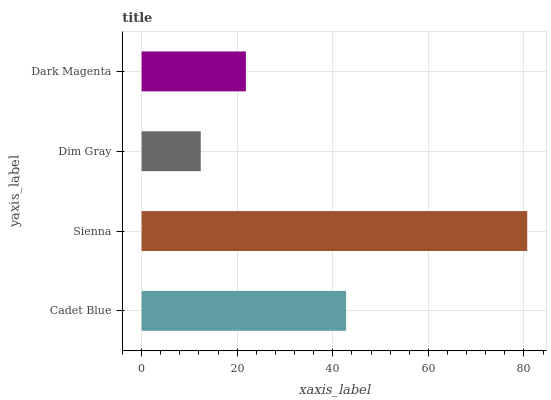Is Dim Gray the minimum?
Answer yes or no. Yes. Is Sienna the maximum?
Answer yes or no. Yes. Is Sienna the minimum?
Answer yes or no. No. Is Dim Gray the maximum?
Answer yes or no. No. Is Sienna greater than Dim Gray?
Answer yes or no. Yes. Is Dim Gray less than Sienna?
Answer yes or no. Yes. Is Dim Gray greater than Sienna?
Answer yes or no. No. Is Sienna less than Dim Gray?
Answer yes or no. No. Is Cadet Blue the high median?
Answer yes or no. Yes. Is Dark Magenta the low median?
Answer yes or no. Yes. Is Dark Magenta the high median?
Answer yes or no. No. Is Cadet Blue the low median?
Answer yes or no. No. 